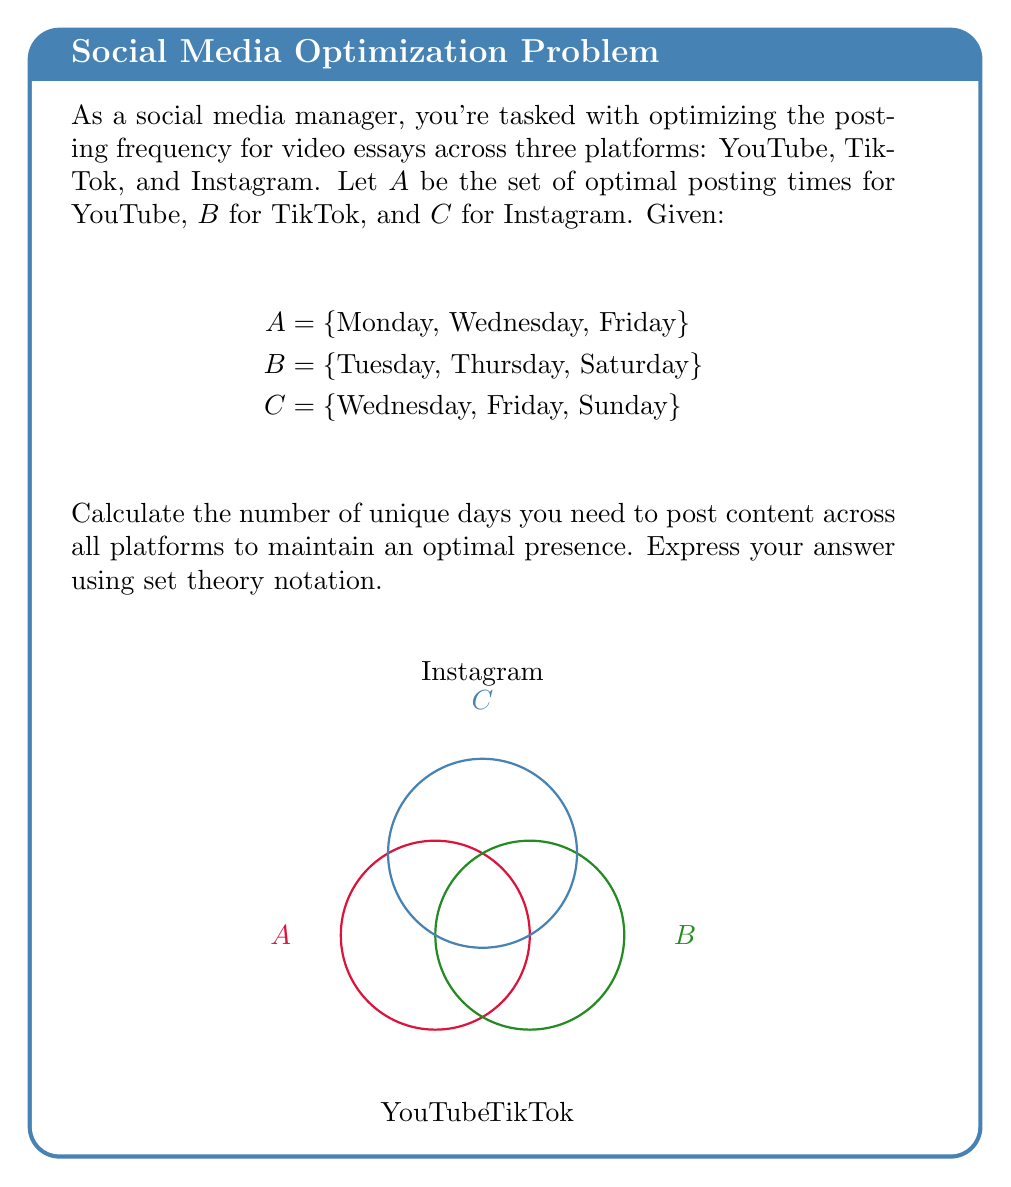What is the answer to this math problem? To solve this problem, we need to find the union of all three sets, which will give us the total number of unique days for posting across all platforms. Let's approach this step-by-step:

1) First, let's write out the union operation:
   $$|A \cup B \cup C|$$

2) We can use the principle of inclusion-exclusion to calculate this:
   $$|A \cup B \cup C| = |A| + |B| + |C| - |A \cap B| - |B \cap C| - |A \cap C| + |A \cap B \cap C|$$

3) Let's calculate each term:
   - $|A| = 3$ (Monday, Wednesday, Friday)
   - $|B| = 3$ (Tuesday, Thursday, Saturday)
   - $|C| = 3$ (Wednesday, Friday, Sunday)
   - $|A \cap B| = 0$ (no common days)
   - $|B \cap C| = 0$ (no common days)
   - $|A \cap C| = 2$ (Wednesday, Friday)
   - $|A \cap B \cap C| = 0$ (no day common to all three)

4) Now, let's substitute these values into our equation:
   $$|A \cup B \cup C| = 3 + 3 + 3 - 0 - 0 - 2 + 0 = 7$$

Therefore, the number of unique days needed to post content across all platforms to maintain an optimal presence is 7.
Answer: $|A \cup B \cup C| = 7$ 